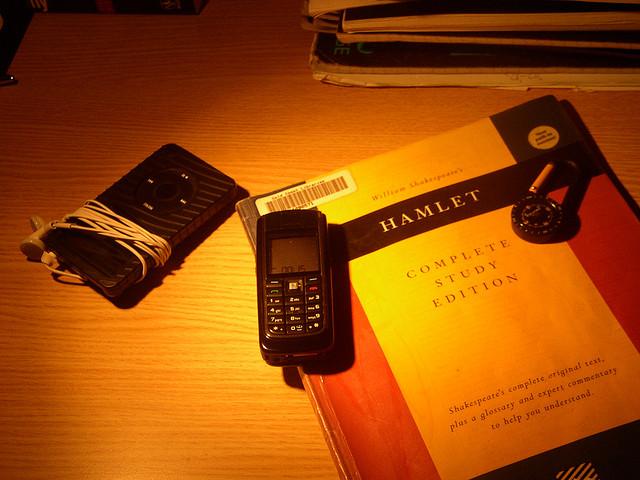How many electronics are in this photo?
Keep it brief. 2. What color are the headphones?
Give a very brief answer. White. What are the items on top of the book?
Give a very brief answer. Lock and phone. 